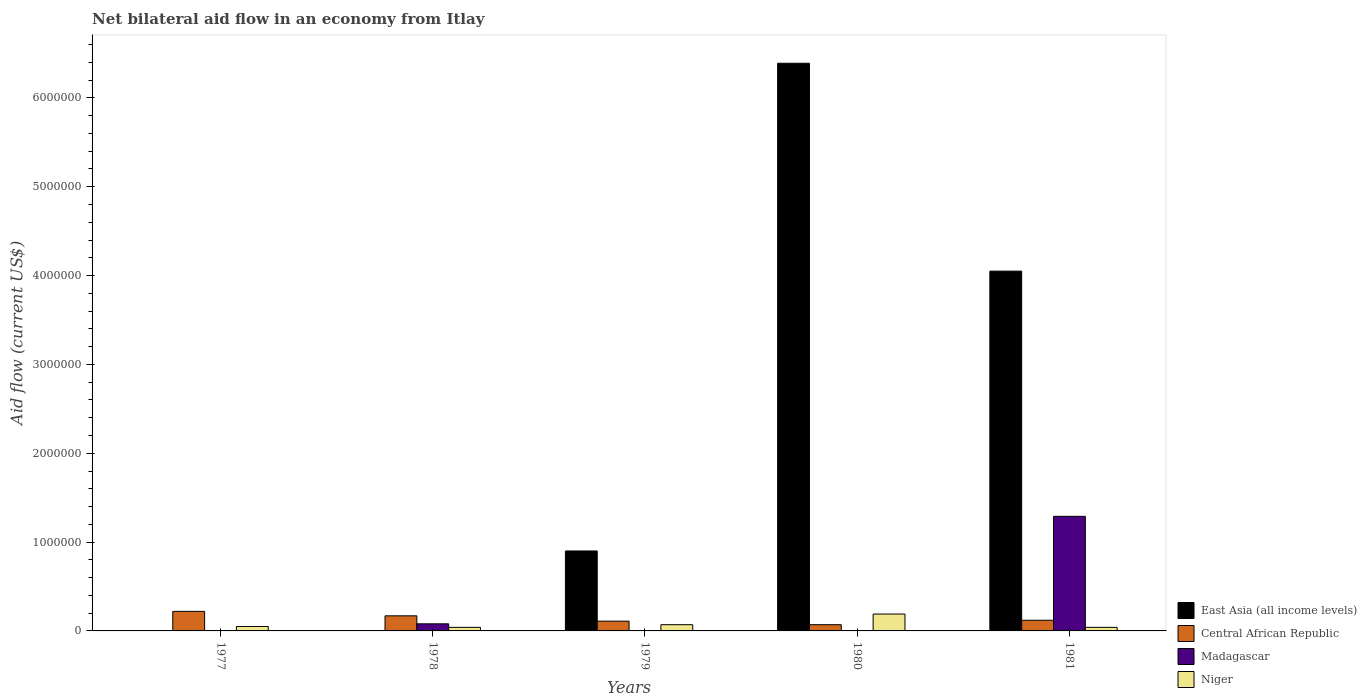What is the label of the 5th group of bars from the left?
Give a very brief answer. 1981. Across all years, what is the minimum net bilateral aid flow in Madagascar?
Provide a succinct answer. 0. In which year was the net bilateral aid flow in East Asia (all income levels) maximum?
Make the answer very short. 1980. What is the total net bilateral aid flow in Central African Republic in the graph?
Your response must be concise. 6.90e+05. What is the difference between the net bilateral aid flow in East Asia (all income levels) in 1977 and the net bilateral aid flow in Niger in 1978?
Give a very brief answer. -4.00e+04. What is the average net bilateral aid flow in Central African Republic per year?
Offer a very short reply. 1.38e+05. In the year 1979, what is the difference between the net bilateral aid flow in Central African Republic and net bilateral aid flow in East Asia (all income levels)?
Your response must be concise. -7.90e+05. In how many years, is the net bilateral aid flow in Niger greater than 2400000 US$?
Provide a short and direct response. 0. What is the ratio of the net bilateral aid flow in Niger in 1977 to that in 1979?
Ensure brevity in your answer.  0.71. Is the net bilateral aid flow in Niger in 1980 less than that in 1981?
Your answer should be very brief. No. What is the difference between the highest and the lowest net bilateral aid flow in Central African Republic?
Provide a short and direct response. 1.50e+05. In how many years, is the net bilateral aid flow in Niger greater than the average net bilateral aid flow in Niger taken over all years?
Your answer should be compact. 1. Is it the case that in every year, the sum of the net bilateral aid flow in Niger and net bilateral aid flow in Central African Republic is greater than the sum of net bilateral aid flow in Madagascar and net bilateral aid flow in East Asia (all income levels)?
Give a very brief answer. No. How many bars are there?
Your answer should be compact. 15. Are all the bars in the graph horizontal?
Your response must be concise. No. How many years are there in the graph?
Make the answer very short. 5. What is the difference between two consecutive major ticks on the Y-axis?
Keep it short and to the point. 1.00e+06. Does the graph contain any zero values?
Offer a terse response. Yes. What is the title of the graph?
Give a very brief answer. Net bilateral aid flow in an economy from Itlay. Does "Ireland" appear as one of the legend labels in the graph?
Make the answer very short. No. What is the label or title of the Y-axis?
Make the answer very short. Aid flow (current US$). What is the Aid flow (current US$) in Central African Republic in 1977?
Give a very brief answer. 2.20e+05. What is the Aid flow (current US$) of Madagascar in 1977?
Give a very brief answer. 0. What is the Aid flow (current US$) in Central African Republic in 1978?
Your answer should be compact. 1.70e+05. What is the Aid flow (current US$) in Niger in 1978?
Offer a terse response. 4.00e+04. What is the Aid flow (current US$) of East Asia (all income levels) in 1979?
Your answer should be compact. 9.00e+05. What is the Aid flow (current US$) in Central African Republic in 1979?
Keep it short and to the point. 1.10e+05. What is the Aid flow (current US$) of Niger in 1979?
Keep it short and to the point. 7.00e+04. What is the Aid flow (current US$) in East Asia (all income levels) in 1980?
Offer a very short reply. 6.39e+06. What is the Aid flow (current US$) in Madagascar in 1980?
Your response must be concise. 0. What is the Aid flow (current US$) of East Asia (all income levels) in 1981?
Your answer should be compact. 4.05e+06. What is the Aid flow (current US$) in Madagascar in 1981?
Your answer should be compact. 1.29e+06. What is the Aid flow (current US$) of Niger in 1981?
Offer a terse response. 4.00e+04. Across all years, what is the maximum Aid flow (current US$) of East Asia (all income levels)?
Your answer should be compact. 6.39e+06. Across all years, what is the maximum Aid flow (current US$) of Central African Republic?
Keep it short and to the point. 2.20e+05. Across all years, what is the maximum Aid flow (current US$) in Madagascar?
Provide a short and direct response. 1.29e+06. Across all years, what is the maximum Aid flow (current US$) in Niger?
Keep it short and to the point. 1.90e+05. Across all years, what is the minimum Aid flow (current US$) in East Asia (all income levels)?
Offer a terse response. 0. Across all years, what is the minimum Aid flow (current US$) in Central African Republic?
Your response must be concise. 7.00e+04. Across all years, what is the minimum Aid flow (current US$) of Niger?
Offer a very short reply. 4.00e+04. What is the total Aid flow (current US$) in East Asia (all income levels) in the graph?
Keep it short and to the point. 1.13e+07. What is the total Aid flow (current US$) in Central African Republic in the graph?
Provide a short and direct response. 6.90e+05. What is the total Aid flow (current US$) in Madagascar in the graph?
Provide a short and direct response. 1.37e+06. What is the total Aid flow (current US$) of Niger in the graph?
Offer a very short reply. 3.90e+05. What is the difference between the Aid flow (current US$) in Niger in 1977 and that in 1978?
Your response must be concise. 10000. What is the difference between the Aid flow (current US$) of Central African Republic in 1977 and that in 1979?
Give a very brief answer. 1.10e+05. What is the difference between the Aid flow (current US$) in Central African Republic in 1977 and that in 1980?
Ensure brevity in your answer.  1.50e+05. What is the difference between the Aid flow (current US$) in Niger in 1977 and that in 1981?
Your answer should be compact. 10000. What is the difference between the Aid flow (current US$) of Central African Republic in 1978 and that in 1981?
Ensure brevity in your answer.  5.00e+04. What is the difference between the Aid flow (current US$) in Madagascar in 1978 and that in 1981?
Give a very brief answer. -1.21e+06. What is the difference between the Aid flow (current US$) of Niger in 1978 and that in 1981?
Ensure brevity in your answer.  0. What is the difference between the Aid flow (current US$) of East Asia (all income levels) in 1979 and that in 1980?
Provide a succinct answer. -5.49e+06. What is the difference between the Aid flow (current US$) in East Asia (all income levels) in 1979 and that in 1981?
Make the answer very short. -3.15e+06. What is the difference between the Aid flow (current US$) in Central African Republic in 1979 and that in 1981?
Make the answer very short. -10000. What is the difference between the Aid flow (current US$) of Niger in 1979 and that in 1981?
Give a very brief answer. 3.00e+04. What is the difference between the Aid flow (current US$) of East Asia (all income levels) in 1980 and that in 1981?
Ensure brevity in your answer.  2.34e+06. What is the difference between the Aid flow (current US$) of Niger in 1980 and that in 1981?
Offer a very short reply. 1.50e+05. What is the difference between the Aid flow (current US$) in Central African Republic in 1977 and the Aid flow (current US$) in Niger in 1978?
Provide a succinct answer. 1.80e+05. What is the difference between the Aid flow (current US$) of Central African Republic in 1977 and the Aid flow (current US$) of Niger in 1980?
Your response must be concise. 3.00e+04. What is the difference between the Aid flow (current US$) of Central African Republic in 1977 and the Aid flow (current US$) of Madagascar in 1981?
Keep it short and to the point. -1.07e+06. What is the difference between the Aid flow (current US$) in Central African Republic in 1978 and the Aid flow (current US$) in Niger in 1979?
Provide a short and direct response. 1.00e+05. What is the difference between the Aid flow (current US$) in Madagascar in 1978 and the Aid flow (current US$) in Niger in 1979?
Your answer should be very brief. 10000. What is the difference between the Aid flow (current US$) in Central African Republic in 1978 and the Aid flow (current US$) in Madagascar in 1981?
Your answer should be compact. -1.12e+06. What is the difference between the Aid flow (current US$) in East Asia (all income levels) in 1979 and the Aid flow (current US$) in Central African Republic in 1980?
Your answer should be compact. 8.30e+05. What is the difference between the Aid flow (current US$) of East Asia (all income levels) in 1979 and the Aid flow (current US$) of Niger in 1980?
Your answer should be compact. 7.10e+05. What is the difference between the Aid flow (current US$) in East Asia (all income levels) in 1979 and the Aid flow (current US$) in Central African Republic in 1981?
Keep it short and to the point. 7.80e+05. What is the difference between the Aid flow (current US$) of East Asia (all income levels) in 1979 and the Aid flow (current US$) of Madagascar in 1981?
Keep it short and to the point. -3.90e+05. What is the difference between the Aid flow (current US$) in East Asia (all income levels) in 1979 and the Aid flow (current US$) in Niger in 1981?
Give a very brief answer. 8.60e+05. What is the difference between the Aid flow (current US$) of Central African Republic in 1979 and the Aid flow (current US$) of Madagascar in 1981?
Offer a terse response. -1.18e+06. What is the difference between the Aid flow (current US$) in East Asia (all income levels) in 1980 and the Aid flow (current US$) in Central African Republic in 1981?
Ensure brevity in your answer.  6.27e+06. What is the difference between the Aid flow (current US$) of East Asia (all income levels) in 1980 and the Aid flow (current US$) of Madagascar in 1981?
Provide a succinct answer. 5.10e+06. What is the difference between the Aid flow (current US$) of East Asia (all income levels) in 1980 and the Aid flow (current US$) of Niger in 1981?
Give a very brief answer. 6.35e+06. What is the difference between the Aid flow (current US$) of Central African Republic in 1980 and the Aid flow (current US$) of Madagascar in 1981?
Give a very brief answer. -1.22e+06. What is the average Aid flow (current US$) in East Asia (all income levels) per year?
Your response must be concise. 2.27e+06. What is the average Aid flow (current US$) of Central African Republic per year?
Provide a short and direct response. 1.38e+05. What is the average Aid flow (current US$) in Madagascar per year?
Ensure brevity in your answer.  2.74e+05. What is the average Aid flow (current US$) in Niger per year?
Make the answer very short. 7.80e+04. In the year 1978, what is the difference between the Aid flow (current US$) in Central African Republic and Aid flow (current US$) in Madagascar?
Give a very brief answer. 9.00e+04. In the year 1978, what is the difference between the Aid flow (current US$) of Madagascar and Aid flow (current US$) of Niger?
Give a very brief answer. 4.00e+04. In the year 1979, what is the difference between the Aid flow (current US$) of East Asia (all income levels) and Aid flow (current US$) of Central African Republic?
Keep it short and to the point. 7.90e+05. In the year 1979, what is the difference between the Aid flow (current US$) of East Asia (all income levels) and Aid flow (current US$) of Niger?
Provide a succinct answer. 8.30e+05. In the year 1980, what is the difference between the Aid flow (current US$) of East Asia (all income levels) and Aid flow (current US$) of Central African Republic?
Make the answer very short. 6.32e+06. In the year 1980, what is the difference between the Aid flow (current US$) of East Asia (all income levels) and Aid flow (current US$) of Niger?
Provide a succinct answer. 6.20e+06. In the year 1981, what is the difference between the Aid flow (current US$) of East Asia (all income levels) and Aid flow (current US$) of Central African Republic?
Your answer should be compact. 3.93e+06. In the year 1981, what is the difference between the Aid flow (current US$) of East Asia (all income levels) and Aid flow (current US$) of Madagascar?
Make the answer very short. 2.76e+06. In the year 1981, what is the difference between the Aid flow (current US$) in East Asia (all income levels) and Aid flow (current US$) in Niger?
Provide a succinct answer. 4.01e+06. In the year 1981, what is the difference between the Aid flow (current US$) in Central African Republic and Aid flow (current US$) in Madagascar?
Provide a short and direct response. -1.17e+06. In the year 1981, what is the difference between the Aid flow (current US$) in Madagascar and Aid flow (current US$) in Niger?
Your answer should be very brief. 1.25e+06. What is the ratio of the Aid flow (current US$) in Central African Republic in 1977 to that in 1978?
Offer a terse response. 1.29. What is the ratio of the Aid flow (current US$) in Niger in 1977 to that in 1978?
Provide a short and direct response. 1.25. What is the ratio of the Aid flow (current US$) of Central African Republic in 1977 to that in 1980?
Make the answer very short. 3.14. What is the ratio of the Aid flow (current US$) of Niger in 1977 to that in 1980?
Offer a very short reply. 0.26. What is the ratio of the Aid flow (current US$) in Central African Republic in 1977 to that in 1981?
Ensure brevity in your answer.  1.83. What is the ratio of the Aid flow (current US$) in Niger in 1977 to that in 1981?
Offer a very short reply. 1.25. What is the ratio of the Aid flow (current US$) of Central African Republic in 1978 to that in 1979?
Provide a short and direct response. 1.55. What is the ratio of the Aid flow (current US$) in Niger in 1978 to that in 1979?
Give a very brief answer. 0.57. What is the ratio of the Aid flow (current US$) in Central African Republic in 1978 to that in 1980?
Offer a very short reply. 2.43. What is the ratio of the Aid flow (current US$) in Niger in 1978 to that in 1980?
Ensure brevity in your answer.  0.21. What is the ratio of the Aid flow (current US$) in Central African Republic in 1978 to that in 1981?
Make the answer very short. 1.42. What is the ratio of the Aid flow (current US$) of Madagascar in 1978 to that in 1981?
Provide a short and direct response. 0.06. What is the ratio of the Aid flow (current US$) in East Asia (all income levels) in 1979 to that in 1980?
Give a very brief answer. 0.14. What is the ratio of the Aid flow (current US$) in Central African Republic in 1979 to that in 1980?
Your answer should be very brief. 1.57. What is the ratio of the Aid flow (current US$) in Niger in 1979 to that in 1980?
Your response must be concise. 0.37. What is the ratio of the Aid flow (current US$) in East Asia (all income levels) in 1979 to that in 1981?
Provide a short and direct response. 0.22. What is the ratio of the Aid flow (current US$) of Central African Republic in 1979 to that in 1981?
Ensure brevity in your answer.  0.92. What is the ratio of the Aid flow (current US$) in Niger in 1979 to that in 1981?
Offer a very short reply. 1.75. What is the ratio of the Aid flow (current US$) of East Asia (all income levels) in 1980 to that in 1981?
Keep it short and to the point. 1.58. What is the ratio of the Aid flow (current US$) of Central African Republic in 1980 to that in 1981?
Your answer should be very brief. 0.58. What is the ratio of the Aid flow (current US$) of Niger in 1980 to that in 1981?
Your answer should be compact. 4.75. What is the difference between the highest and the second highest Aid flow (current US$) of East Asia (all income levels)?
Your answer should be compact. 2.34e+06. What is the difference between the highest and the second highest Aid flow (current US$) in Central African Republic?
Provide a succinct answer. 5.00e+04. What is the difference between the highest and the lowest Aid flow (current US$) in East Asia (all income levels)?
Keep it short and to the point. 6.39e+06. What is the difference between the highest and the lowest Aid flow (current US$) in Central African Republic?
Keep it short and to the point. 1.50e+05. What is the difference between the highest and the lowest Aid flow (current US$) of Madagascar?
Provide a succinct answer. 1.29e+06. 